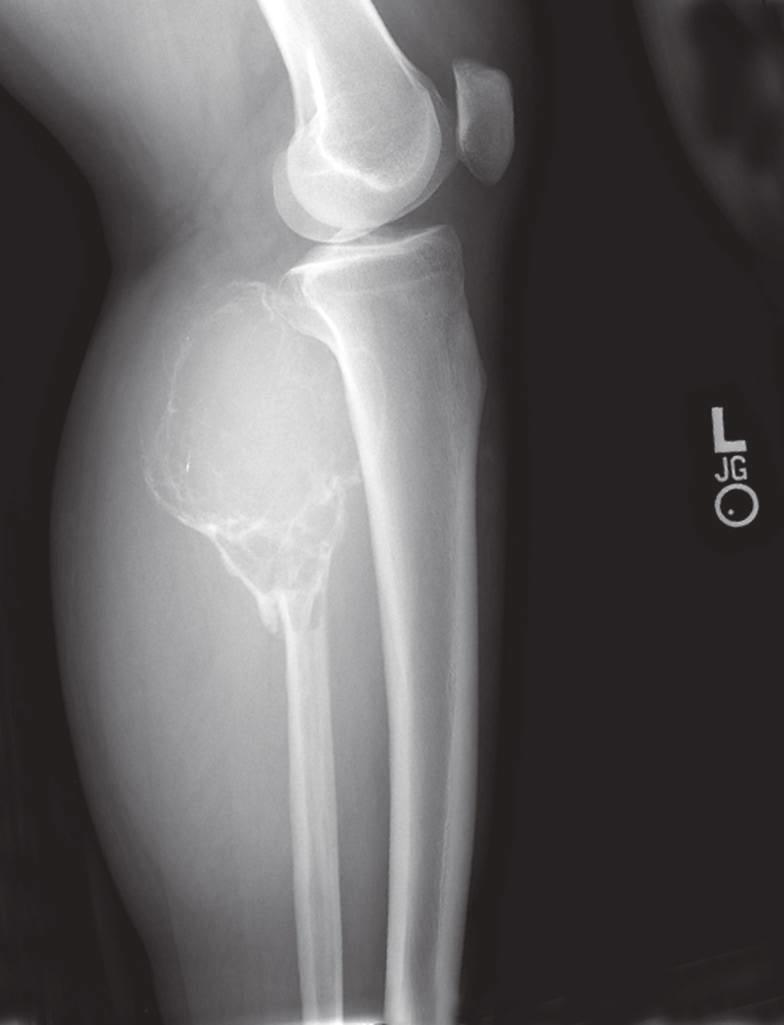s collagen predominantly lytic, expansile with destruction of the cortex?
Answer the question using a single word or phrase. No 